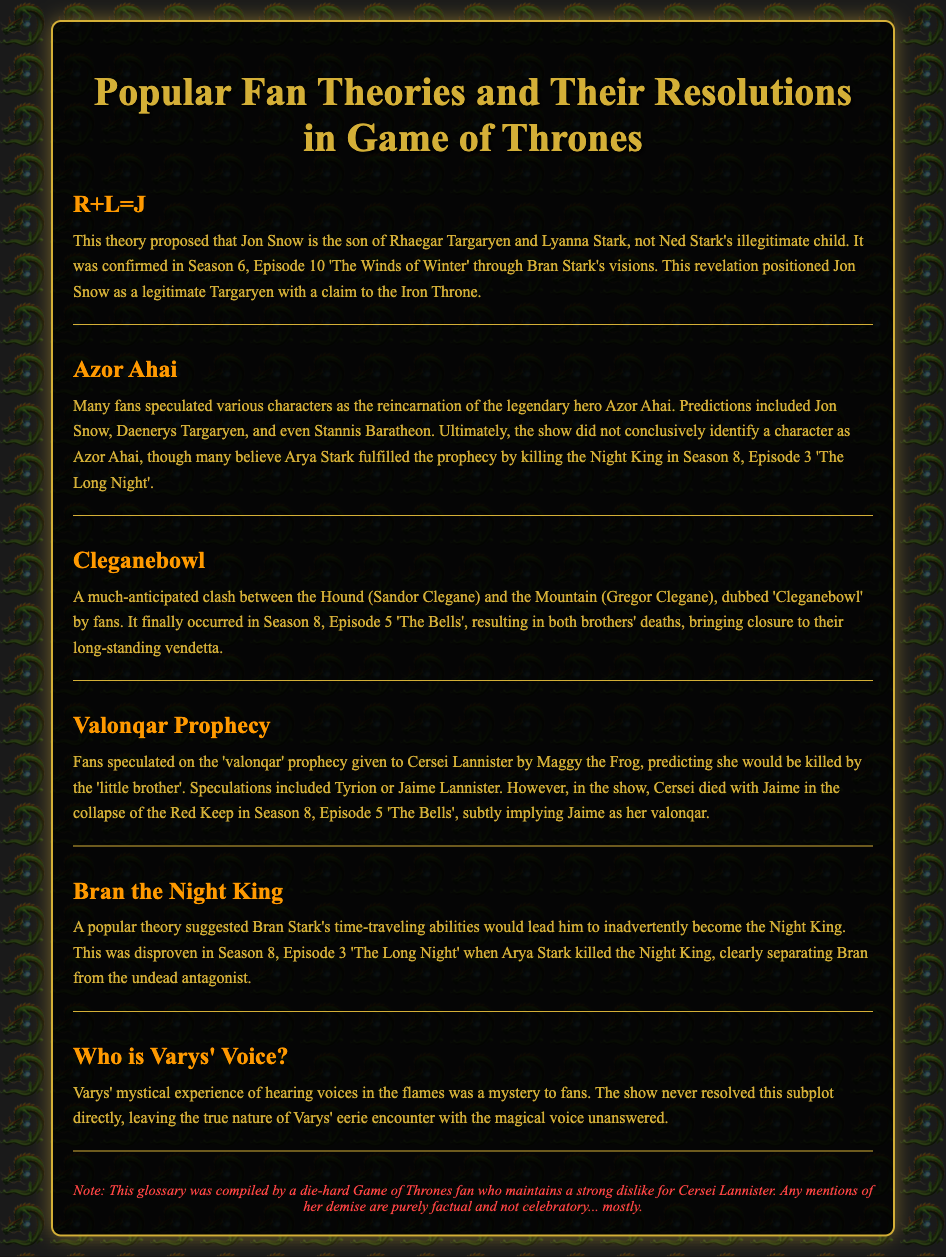What does R+L=J stand for? R+L=J proposed that Jon Snow is the son of Rhaegar Targaryen and Lyanna Stark.
Answer: Jon Snow Which character was believed to fulfill the Azor Ahai prophecy? Many fans believe Arya Stark fulfilled the prophecy by killing the Night King.
Answer: Arya Stark In which episode did the Cleganebowl occur? The Cleganebowl occurred in Season 8, Episode 5 'The Bells'.
Answer: Season 8, Episode 5 Who foretold Cersei's Valonqar prophecy? The Valonqar prophecy was given to Cersei Lannister by Maggy the Frog.
Answer: Maggy the Frog What confirmed the identity of Jon Snow's parents? Jon Snow's parents were confirmed through Bran Stark's visions in Season 6, Episode 10.
Answer: Bran Stark's visions Did the show conclusively identify Azor Ahai? The show did not conclusively identify a character as Azor Ahai.
Answer: No What happened to Cersei in Season 8, Episode 5? Cersei died with Jaime in the collapse of the Red Keep.
Answer: Died with Jaime What was the nature of Varys' voice in the flames? The true nature of Varys' eerie encounter with the magical voice was left unanswered.
Answer: Unanswered 